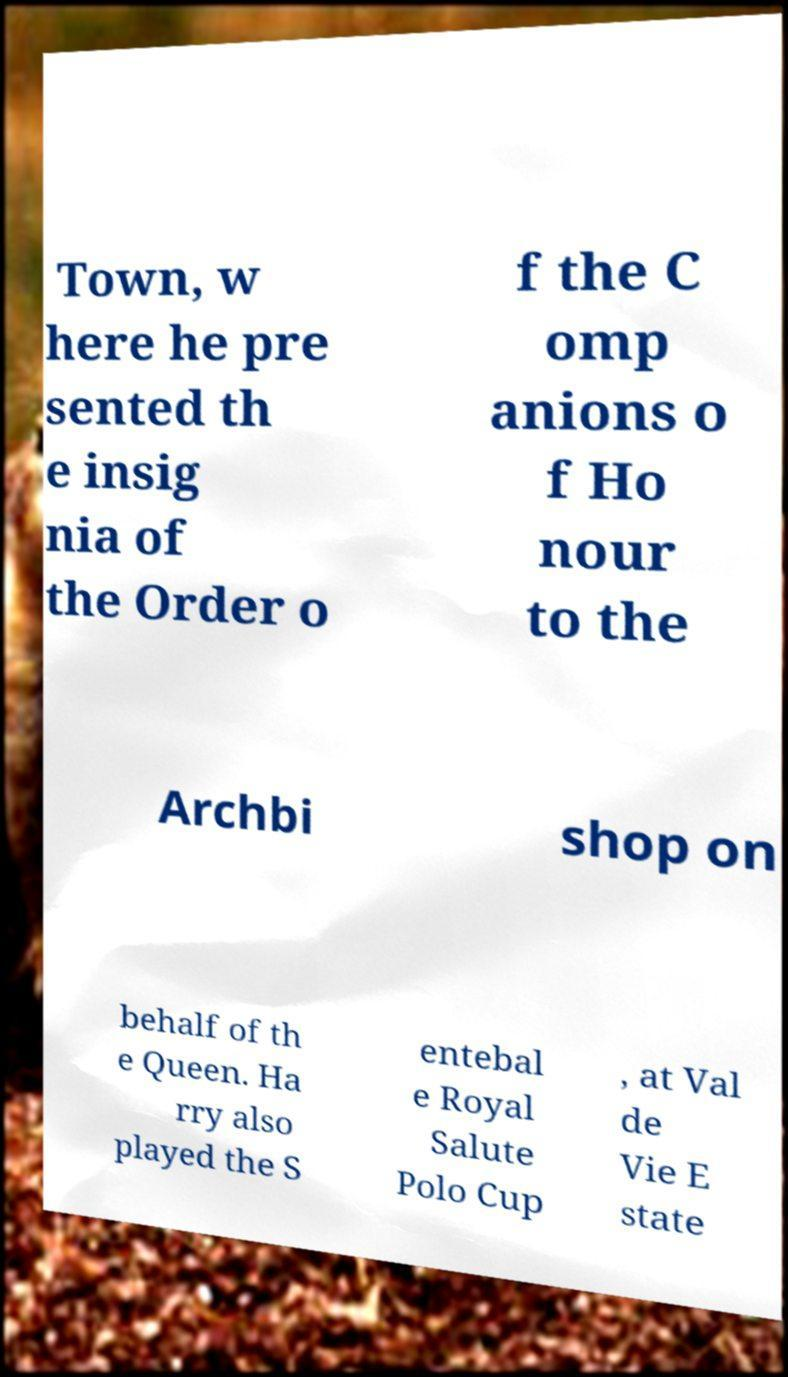Please read and relay the text visible in this image. What does it say? Town, w here he pre sented th e insig nia of the Order o f the C omp anions o f Ho nour to the Archbi shop on behalf of th e Queen. Ha rry also played the S entebal e Royal Salute Polo Cup , at Val de Vie E state 